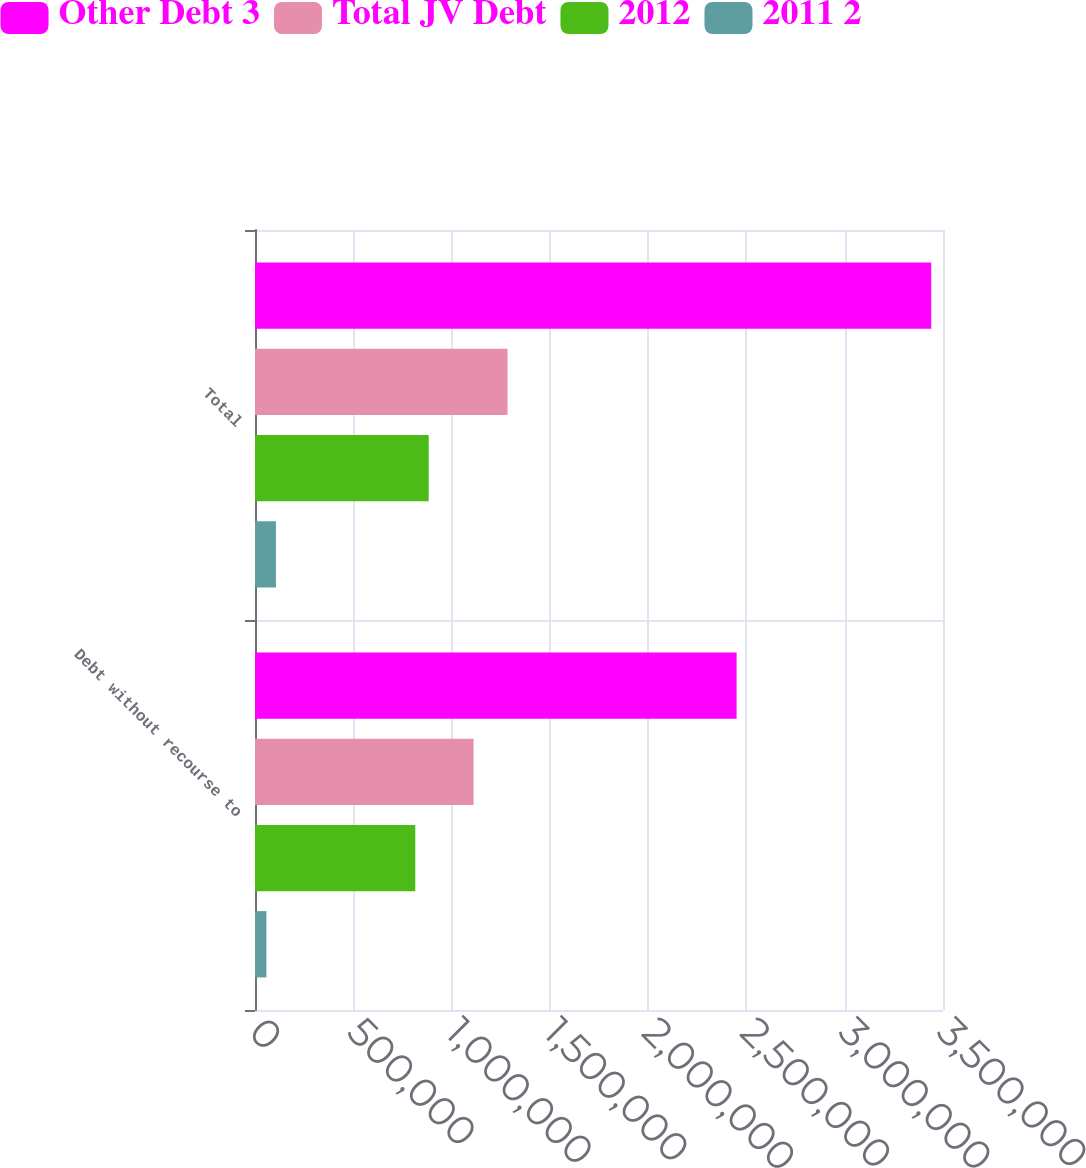<chart> <loc_0><loc_0><loc_500><loc_500><stacked_bar_chart><ecel><fcel>Debt without recourse to<fcel>Total<nl><fcel>Other Debt 3<fcel>2.45005e+06<fcel>3.44008e+06<nl><fcel>Total JV Debt<fcel>1.11197e+06<fcel>1.28482e+06<nl><fcel>2012<fcel>815481<fcel>883718<nl><fcel>2011 2<fcel>58082<fcel>106509<nl></chart> 